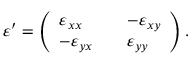Convert formula to latex. <formula><loc_0><loc_0><loc_500><loc_500>\begin{array} { r } { \varepsilon ^ { \prime } = \left ( \begin{array} { l l l } { \varepsilon _ { x x } } & { - \varepsilon _ { x y } } \\ { - \varepsilon _ { y x } } & { \varepsilon _ { y y } } \end{array} \right ) . } \end{array}</formula> 